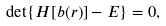Convert formula to latex. <formula><loc_0><loc_0><loc_500><loc_500>\det \{ H [ b ( r ) ] - E \} = 0 ,</formula> 